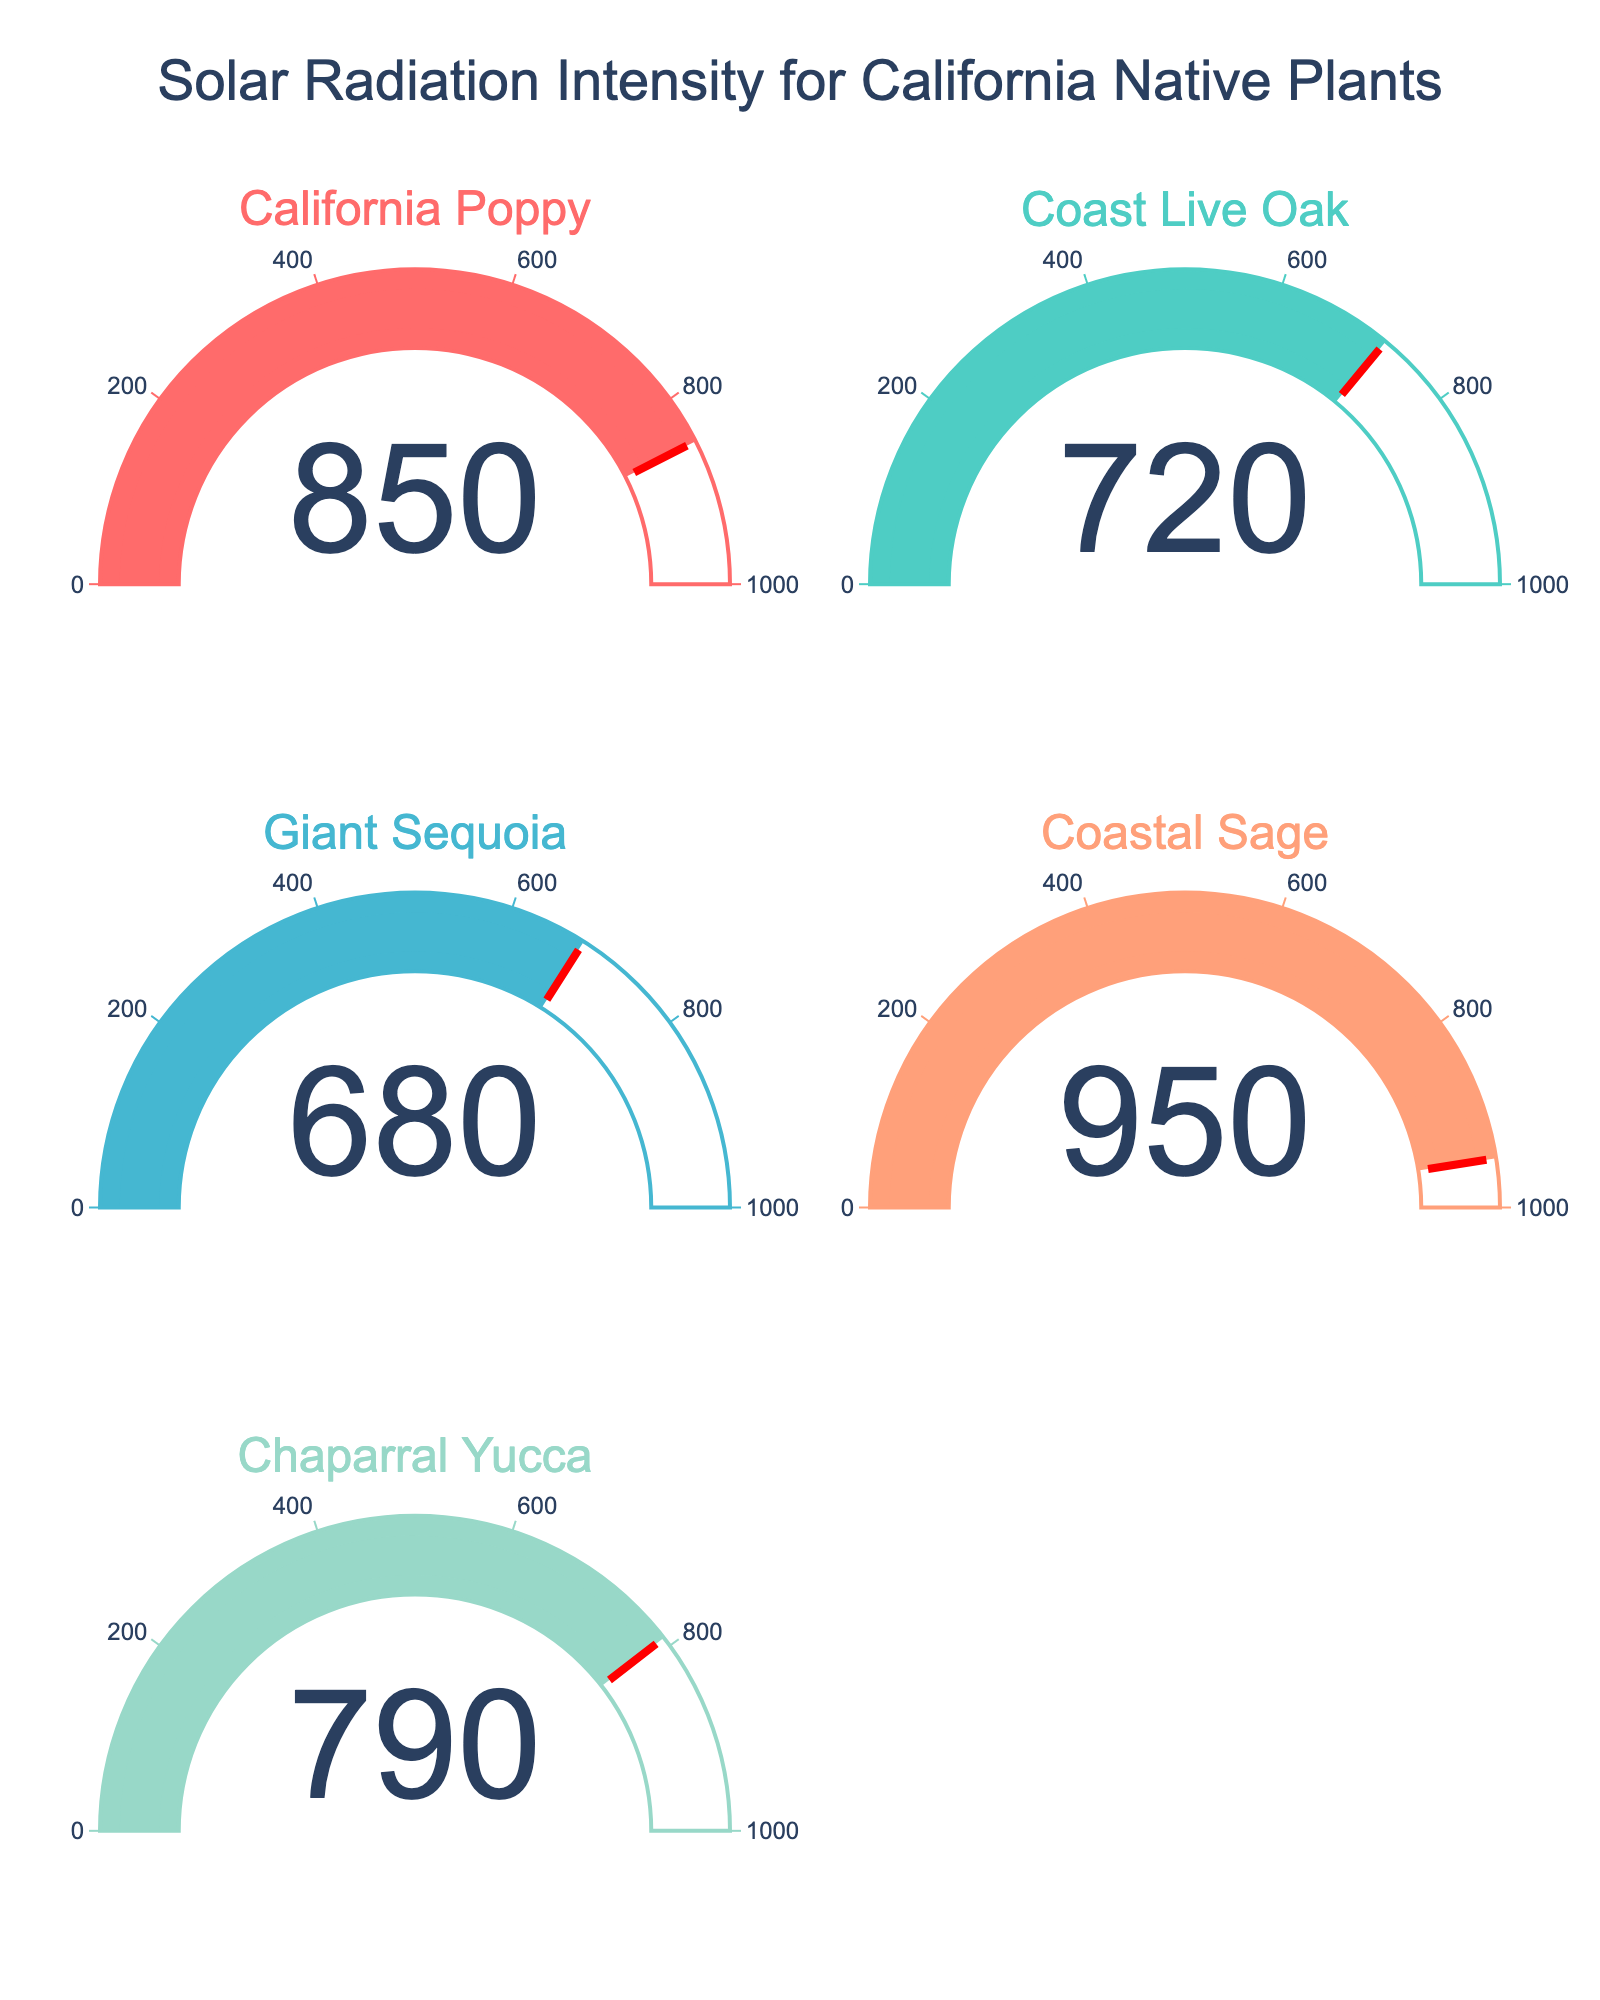What's the title of the figure? The title can be seen at the top of the figure and is usually in a larger and bolder font.
Answer: Solar Radiation Intensity for California Native Plants What's the maximum solar intensity displayed on the gauges? The highest value on the gauges can be identified by looking at the number displayed within the green region of the gauges.
Answer: 950 W/m² How many plants are displayed in the figure? By counting the number of gauges along with the plant names associated with each gauge, we can determine the number of plants.
Answer: 5 Which plant has the lowest solar radiation intensity? By comparing the values displayed on each gauge, the lowest intensity value can be identified.
Answer: Giant Sequoia What is the average solar intensity among all the plants? Add all the solar intensity values: (850 + 720 + 680 + 950 + 790) and then divide by the number of plants, which is 5. The calculation is (850 + 720 + 680 + 950 + 790)/5 = 3990/5 = 798
Answer: 798 W/m² Is the solar intensity of Chaparral Yucca higher or lower than Coast Live Oak? Compare the solar intensity values displayed on the gauges for Chaparral Yucca (790 W/m²) and Coast Live Oak (720 W/m²). 790 is higher than 720.
Answer: Higher What's the difference in solar intensity between California Poppy and Coastal Sage? Subtract the intensity of California Poppy from Coastal Sage: 950 W/m² - 850 W/m² = 100 W/m²
Answer: 100 W/m² Which plant is in the middle in terms of solar radiation intensity? Arrange the plants by their intensity values: 680, 720, 790, 850, 950. The middle value is the third one.
Answer: Chaparral Yucca What color is used for the gauge displaying the solar intensity of Coastal Sage? Identify the color associated with the Coastal Sage gauge.
Answer: Orange (or #FFA07A for more precise identification) Are there any plants with solar intensities greater than 900 W/m²? Check all the gauges and note if any values exceed 900 W/m². Coastal Sage has 950 W/m².
Answer: Yes 